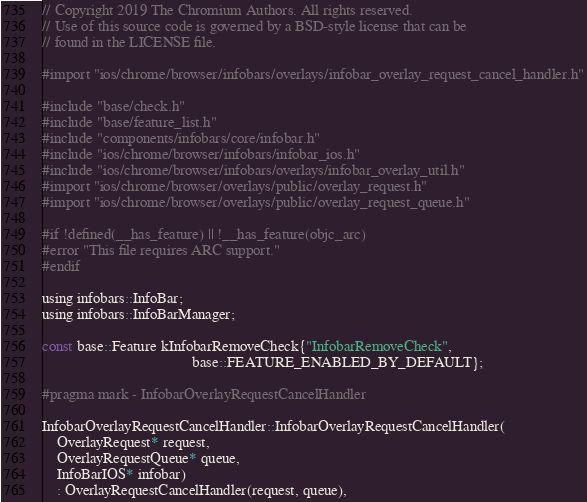<code> <loc_0><loc_0><loc_500><loc_500><_ObjectiveC_>// Copyright 2019 The Chromium Authors. All rights reserved.
// Use of this source code is governed by a BSD-style license that can be
// found in the LICENSE file.

#import "ios/chrome/browser/infobars/overlays/infobar_overlay_request_cancel_handler.h"

#include "base/check.h"
#include "base/feature_list.h"
#include "components/infobars/core/infobar.h"
#include "ios/chrome/browser/infobars/infobar_ios.h"
#include "ios/chrome/browser/infobars/overlays/infobar_overlay_util.h"
#import "ios/chrome/browser/overlays/public/overlay_request.h"
#import "ios/chrome/browser/overlays/public/overlay_request_queue.h"

#if !defined(__has_feature) || !__has_feature(objc_arc)
#error "This file requires ARC support."
#endif

using infobars::InfoBar;
using infobars::InfoBarManager;

const base::Feature kInfobarRemoveCheck{"InfobarRemoveCheck",
                                        base::FEATURE_ENABLED_BY_DEFAULT};

#pragma mark - InfobarOverlayRequestCancelHandler

InfobarOverlayRequestCancelHandler::InfobarOverlayRequestCancelHandler(
    OverlayRequest* request,
    OverlayRequestQueue* queue,
    InfoBarIOS* infobar)
    : OverlayRequestCancelHandler(request, queue),</code> 